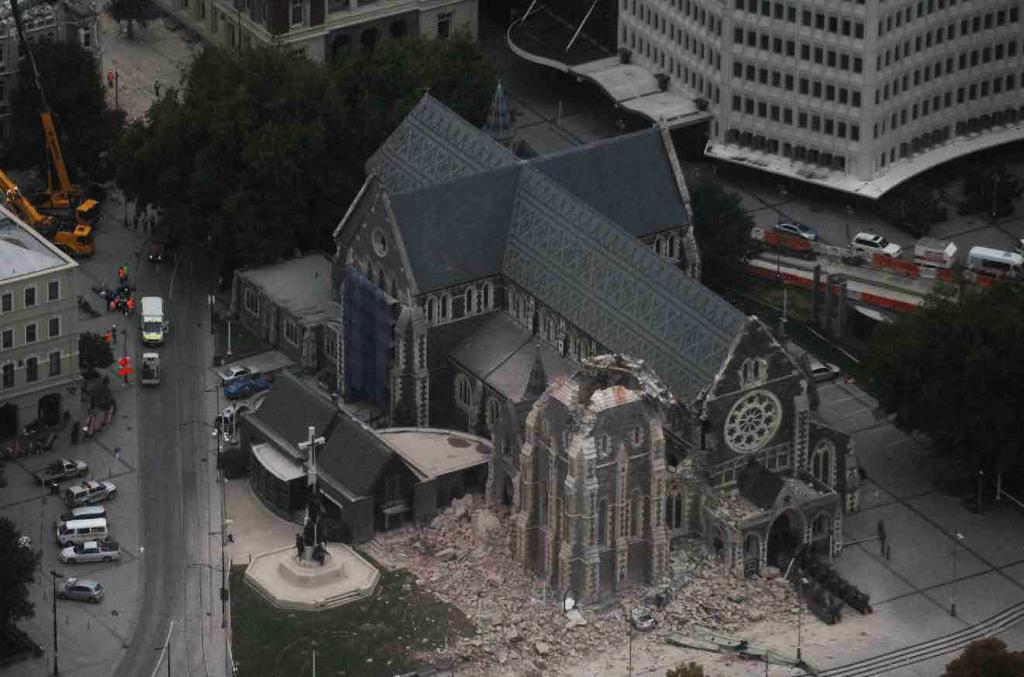What type of structures can be seen in the image? There are buildings in the image. What natural elements are present in the image? There are trees in the image. What are the tall, thin objects in the image? There are poles in the image. What type of transportation can be seen in the image? There are vehicles on the road in the image. What type of current is flowing through the oven in the image? There is no oven present in the image, so it is not possible to determine if there is any current flowing through it. What type of badge is being worn by the trees in the image? There are no badges present in the image, as the trees are natural elements and do not wear badges. 